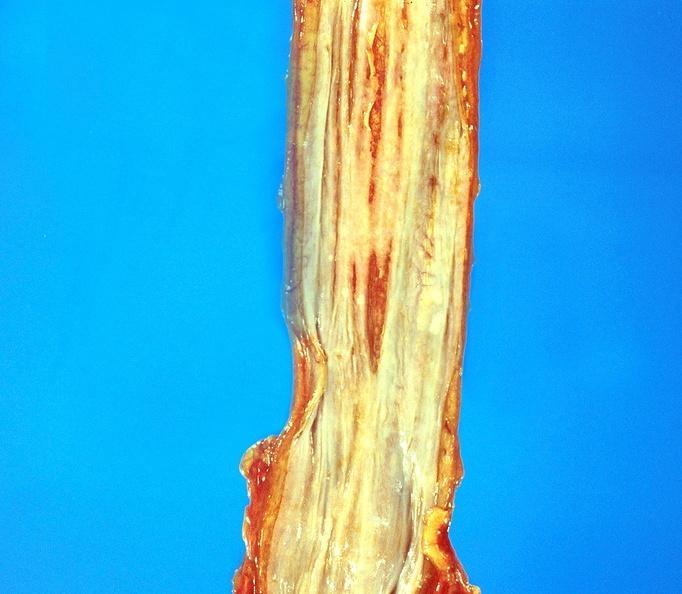does opened muscle show esophageal varices?
Answer the question using a single word or phrase. No 